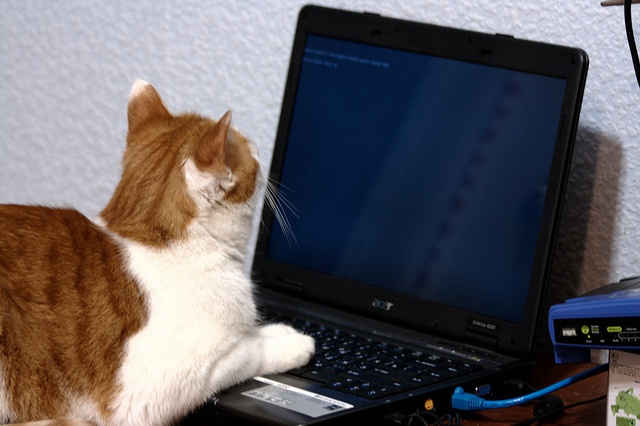Describe the objects in this image and their specific colors. I can see laptop in darkgray, black, navy, and gray tones and cat in darkgray, ivory, maroon, and brown tones in this image. 